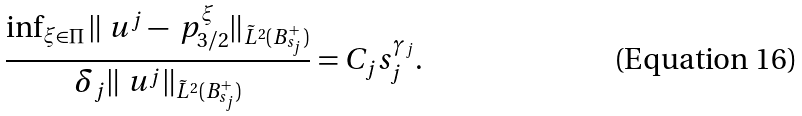<formula> <loc_0><loc_0><loc_500><loc_500>\frac { \inf _ { \xi \in \Pi } \| \ u ^ { j } - \ p _ { 3 / 2 } ^ { \xi } \| _ { \tilde { L } ^ { 2 } ( B _ { s _ { j } } ^ { + } ) } } { \delta _ { j } \| \ u ^ { j } \| _ { \tilde { L } ^ { 2 } ( B _ { s _ { j } } ^ { + } ) } } = C _ { j } s _ { j } ^ { \gamma _ { j } } .</formula> 